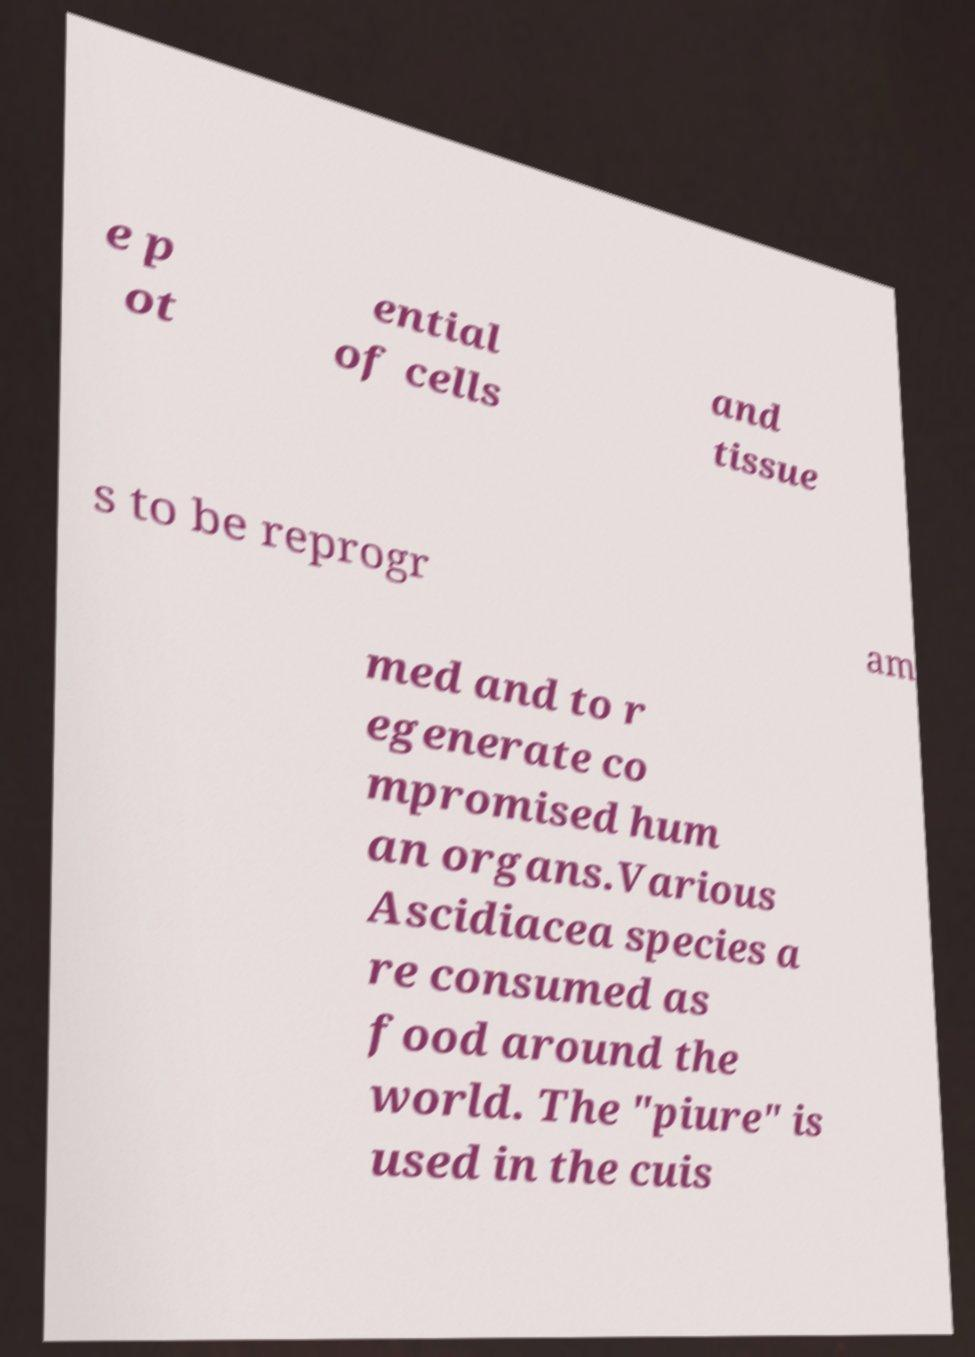There's text embedded in this image that I need extracted. Can you transcribe it verbatim? e p ot ential of cells and tissue s to be reprogr am med and to r egenerate co mpromised hum an organs.Various Ascidiacea species a re consumed as food around the world. The "piure" is used in the cuis 